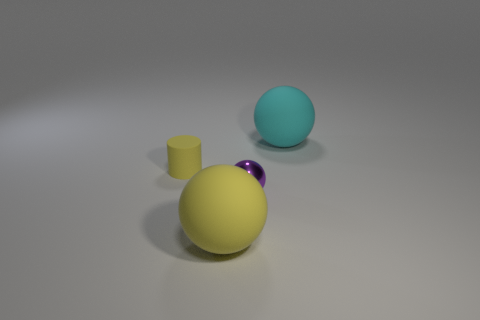Are there any other things that are the same material as the purple thing?
Give a very brief answer. No. How many big green shiny blocks are there?
Offer a very short reply. 0. What color is the tiny cylinder that is the same material as the yellow ball?
Give a very brief answer. Yellow. How many large objects are matte cylinders or rubber balls?
Offer a very short reply. 2. What number of rubber objects are behind the rubber cylinder?
Your answer should be very brief. 1. What color is the tiny metallic object that is the same shape as the large cyan object?
Provide a succinct answer. Purple. How many matte things are either big green cylinders or big yellow things?
Give a very brief answer. 1. There is a matte ball left of the matte ball behind the large yellow object; is there a big matte thing on the right side of it?
Your answer should be compact. Yes. What is the color of the matte cylinder?
Keep it short and to the point. Yellow. Is the shape of the large object that is behind the yellow sphere the same as  the large yellow object?
Your answer should be compact. Yes. 